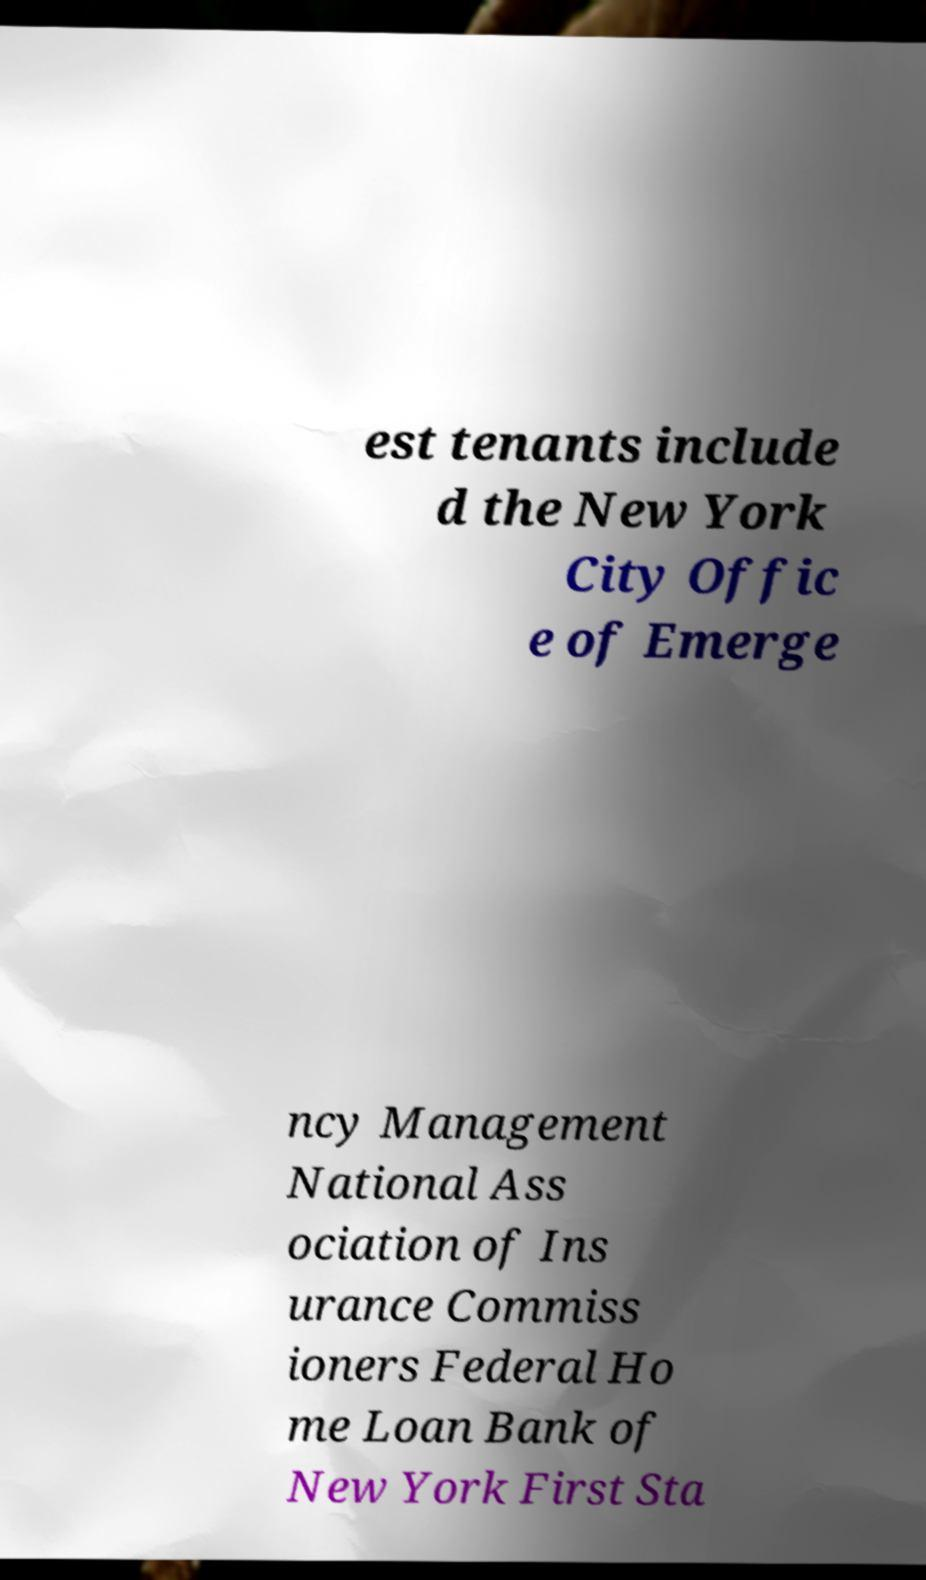Can you accurately transcribe the text from the provided image for me? est tenants include d the New York City Offic e of Emerge ncy Management National Ass ociation of Ins urance Commiss ioners Federal Ho me Loan Bank of New York First Sta 